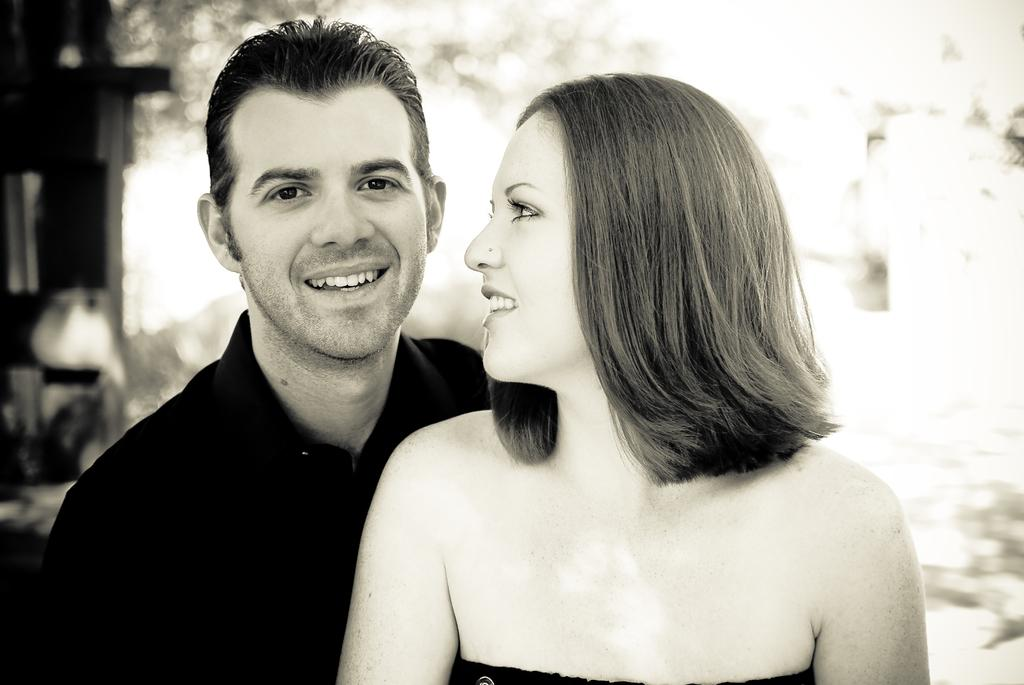Who is present in the image? There is a man and a woman in the image. What are the facial expressions of the people in the image? The man and the woman are both smiling in the image. What can be seen in the background of the image? There are objects in the background of the image, but they are blurry. What type of sea creature can be seen fighting in the background of the image? There is no sea creature present in the image, nor is there any fighting depicted. 